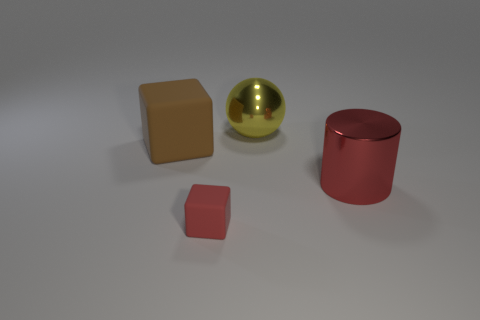There is a matte object that is the same color as the large cylinder; what size is it?
Your answer should be compact. Small. Are there any other things that are the same size as the cylinder?
Offer a very short reply. Yes. Do the large red object and the large brown cube have the same material?
Give a very brief answer. No. What number of things are either brown matte objects left of the red metallic cylinder or rubber objects that are behind the small block?
Keep it short and to the point. 1. Is there a rubber block of the same size as the metallic ball?
Give a very brief answer. Yes. There is another tiny rubber object that is the same shape as the brown thing; what is its color?
Ensure brevity in your answer.  Red. There is a large metal thing behind the brown cube; are there any metallic things that are behind it?
Offer a very short reply. No. Does the rubber object that is behind the big red object have the same shape as the red matte thing?
Your answer should be compact. Yes. The tiny red thing has what shape?
Your response must be concise. Cube. How many big brown things are made of the same material as the tiny red object?
Your response must be concise. 1. 